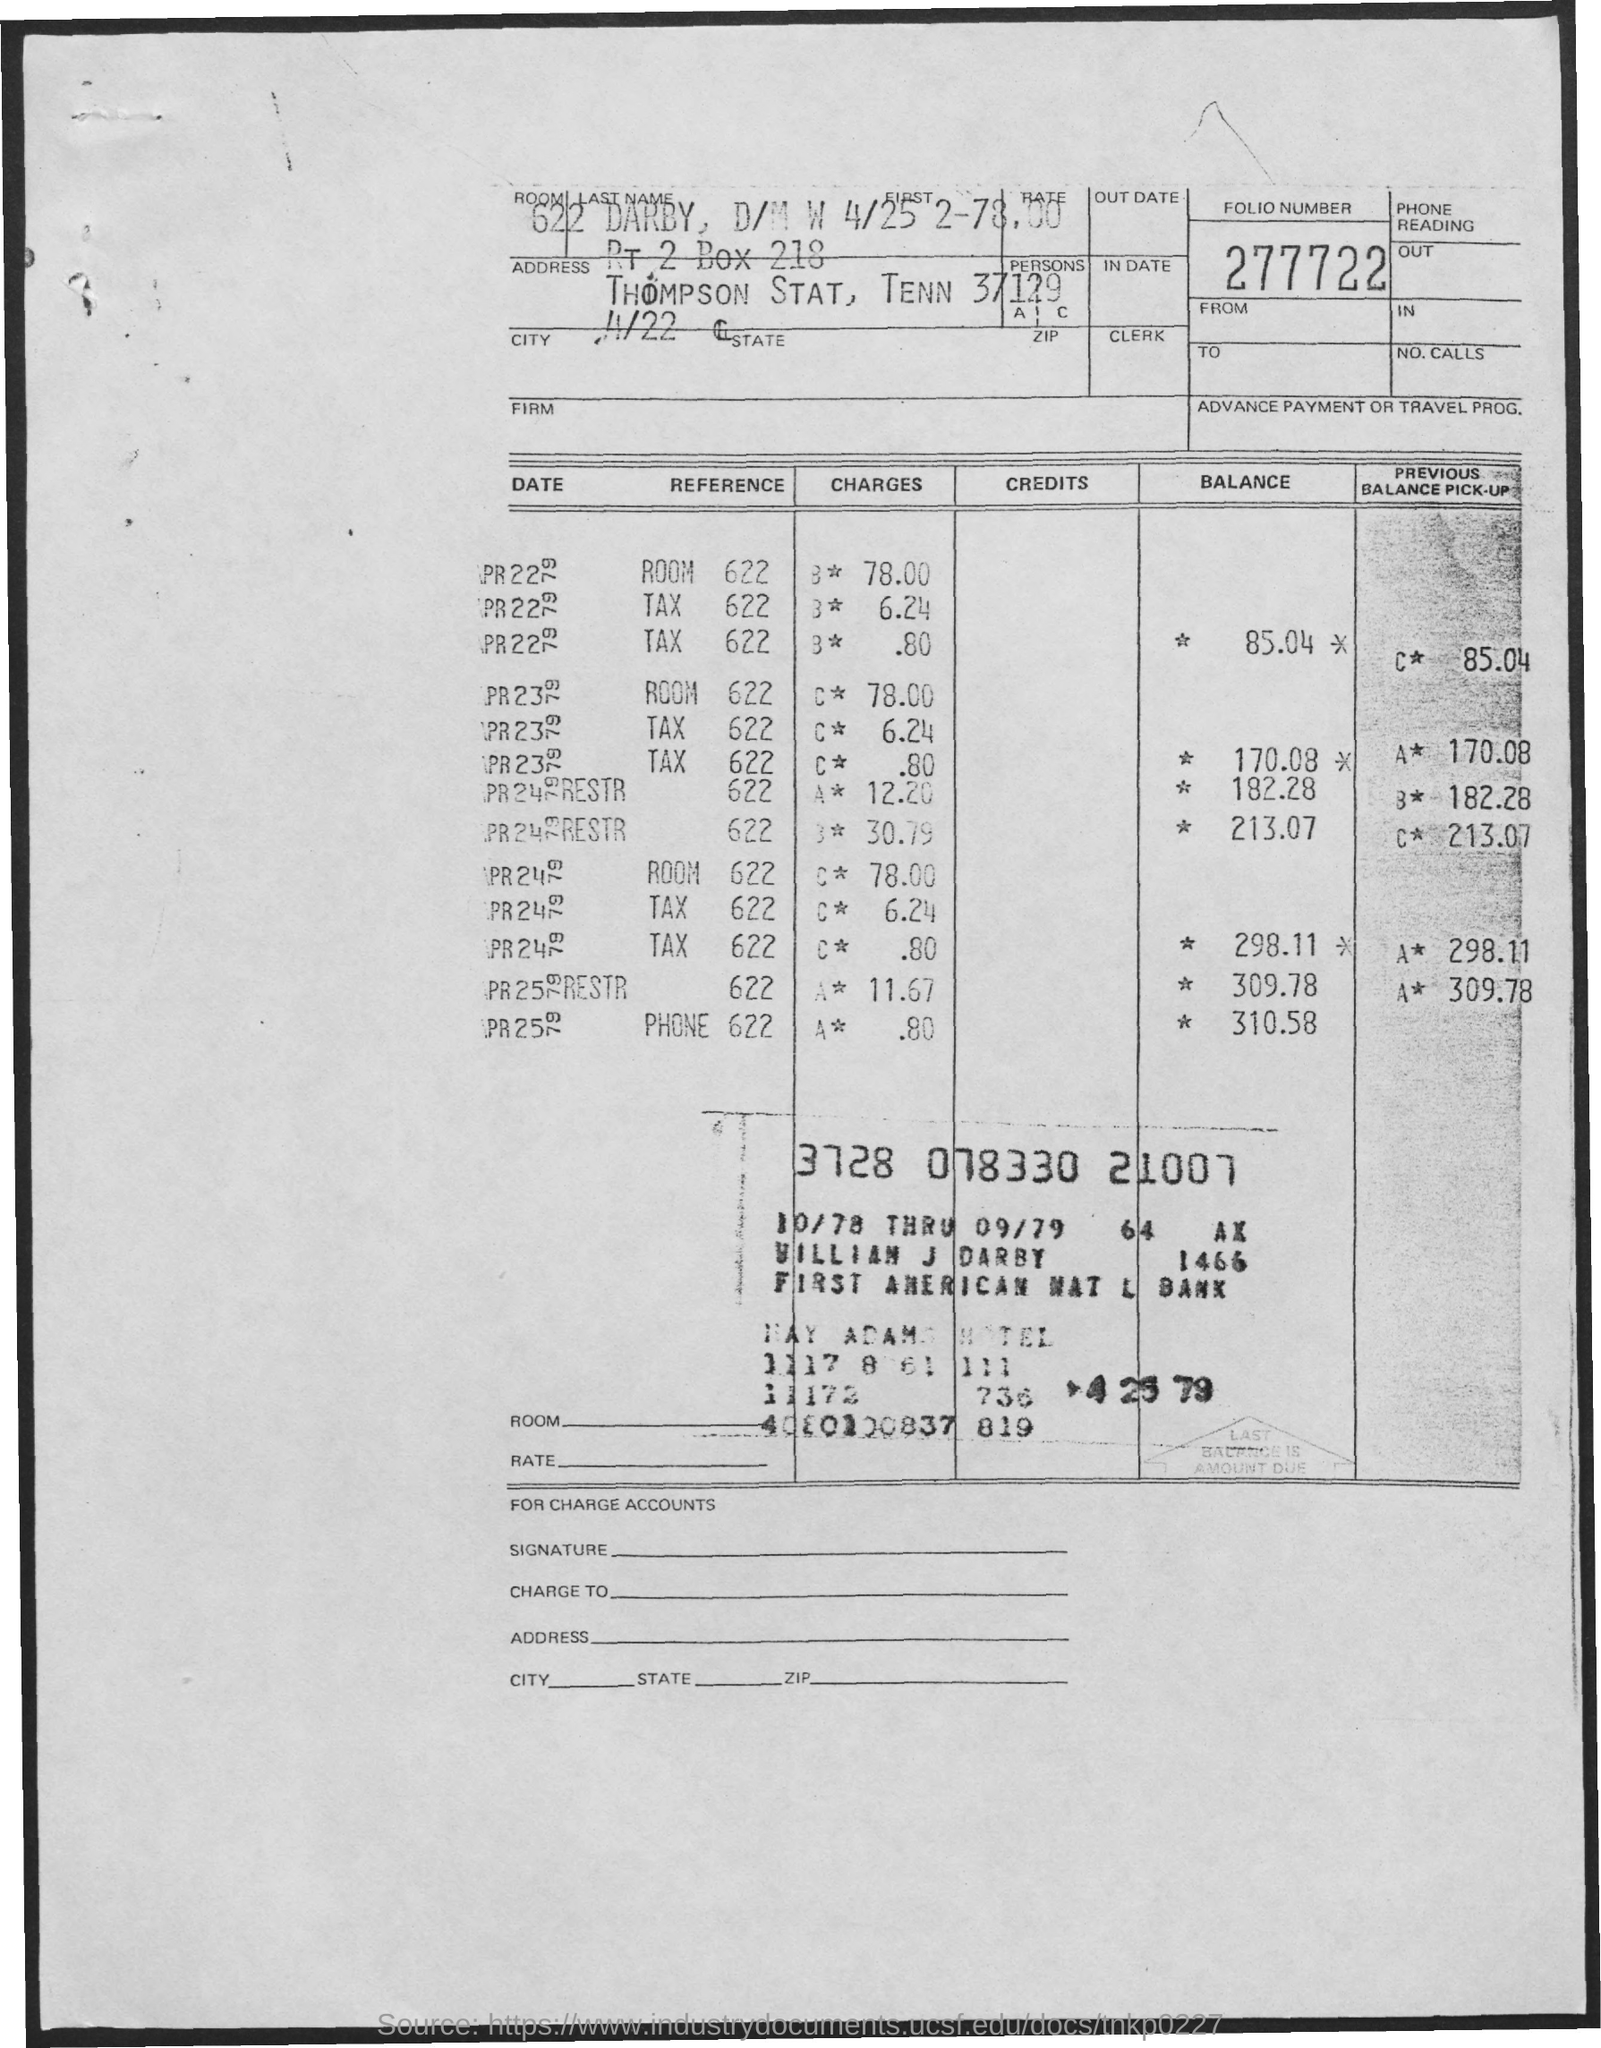What is the folio number?
Provide a short and direct response. 277722. What is the room number?
Make the answer very short. 622. 